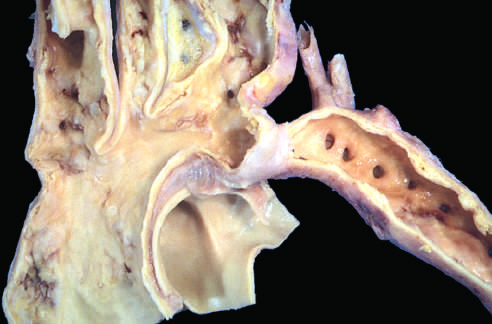do such lesions manifest later in life than preductal coarctations?
Answer the question using a single word or phrase. Yes 